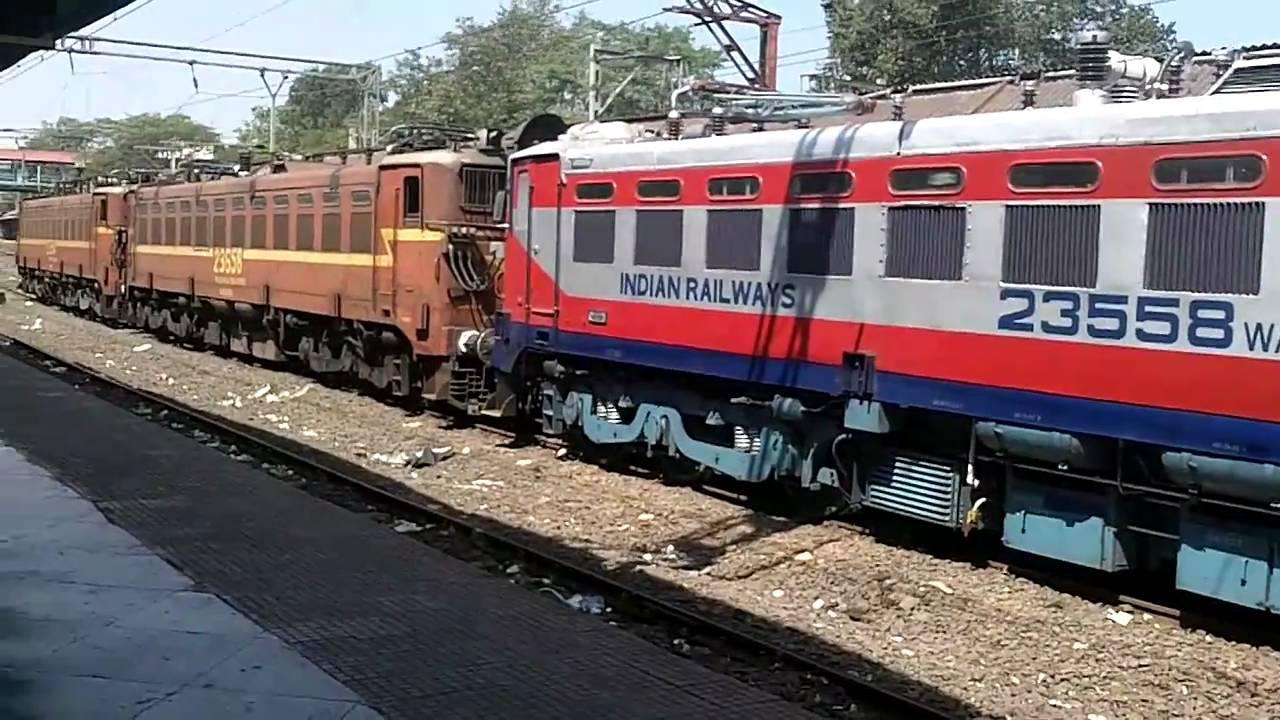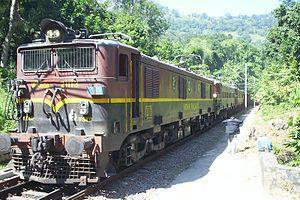The first image is the image on the left, the second image is the image on the right. For the images displayed, is the sentence "An image shows a train with stripes of blue on the bottom, followed by red, white, red, and white on top." factually correct? Answer yes or no. Yes. The first image is the image on the left, the second image is the image on the right. Considering the images on both sides, is "Each of the images shows a train pointed in the same direction." valid? Answer yes or no. No. 